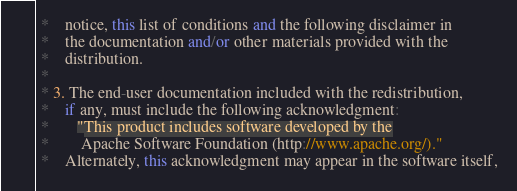<code> <loc_0><loc_0><loc_500><loc_500><_C++_> *    notice, this list of conditions and the following disclaimer in
 *    the documentation and/or other materials provided with the
 *    distribution.
 * 
 * 3. The end-user documentation included with the redistribution,
 *    if any, must include the following acknowledgment:  
 *       "This product includes software developed by the
 *        Apache Software Foundation (http://www.apache.org/)."
 *    Alternately, this acknowledgment may appear in the software itself,</code> 